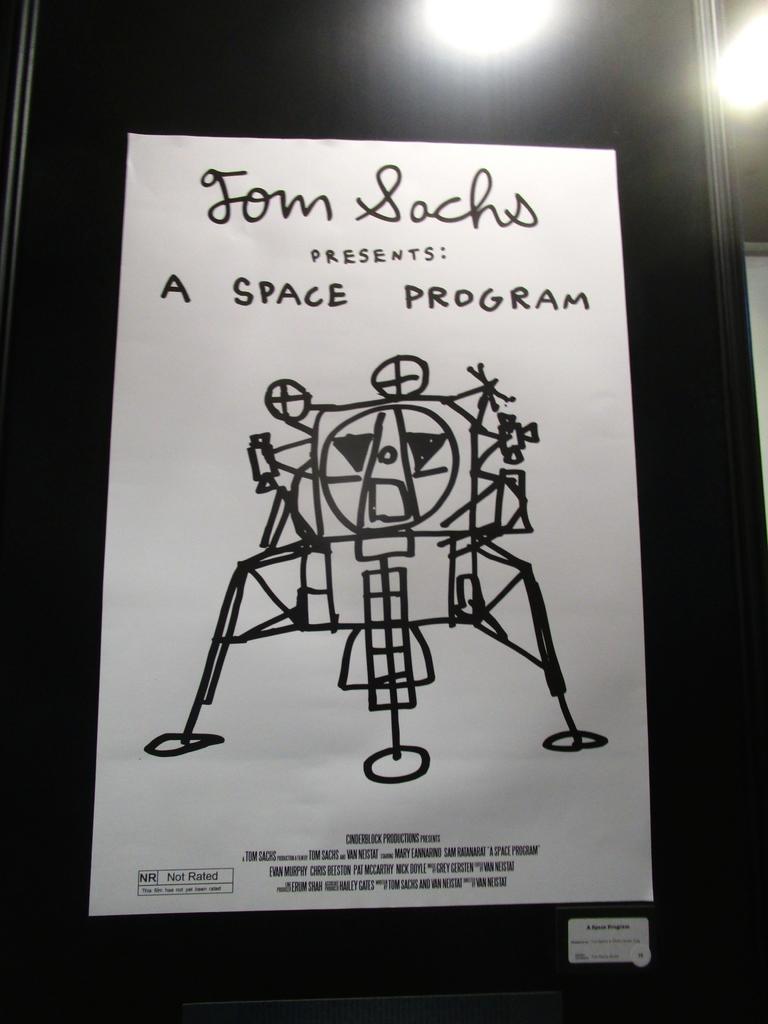What is tom sachs presenting?
Provide a short and direct response. A space program. What kind of program is mentioned?
Keep it short and to the point. Space. 